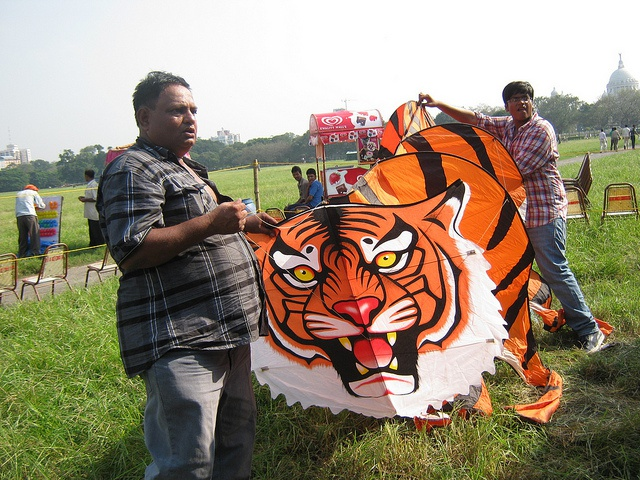Describe the objects in this image and their specific colors. I can see kite in lightgray, red, black, white, and darkgray tones, people in lightgray, black, gray, and darkgray tones, people in lightgray, maroon, black, and gray tones, chair in lightgray, tan, and olive tones, and people in lightgray, black, white, gray, and darkgray tones in this image. 